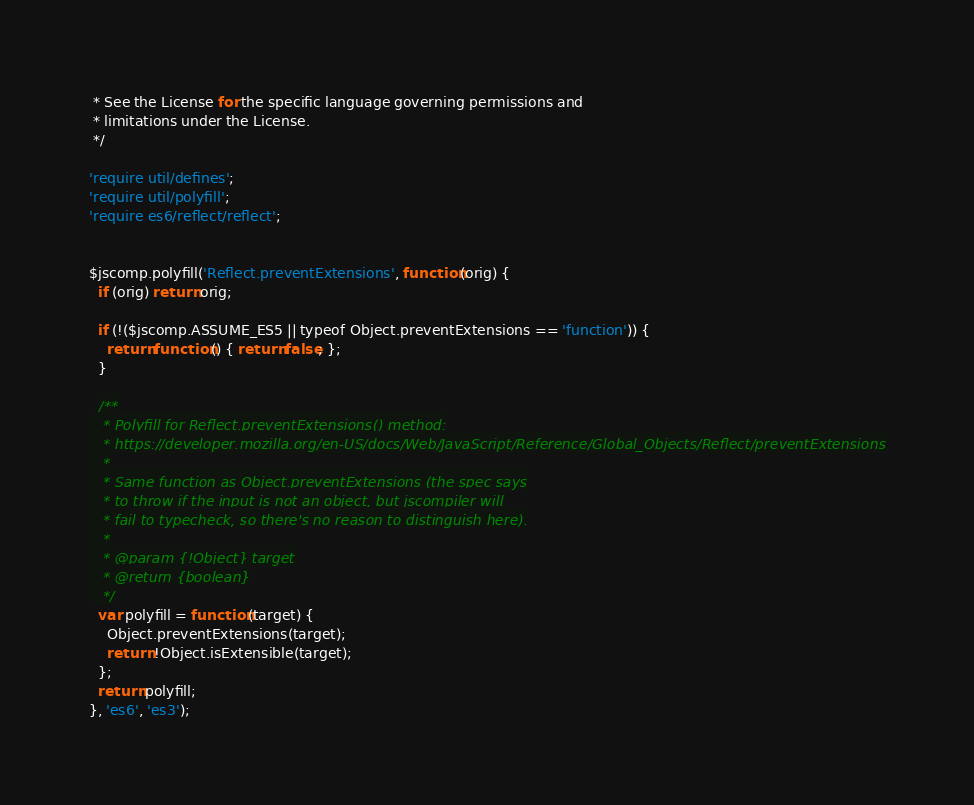<code> <loc_0><loc_0><loc_500><loc_500><_JavaScript_> * See the License for the specific language governing permissions and
 * limitations under the License.
 */

'require util/defines';
'require util/polyfill';
'require es6/reflect/reflect';


$jscomp.polyfill('Reflect.preventExtensions', function(orig) {
  if (orig) return orig;

  if (!($jscomp.ASSUME_ES5 || typeof Object.preventExtensions == 'function')) {
    return function() { return false; };
  }

  /**
   * Polyfill for Reflect.preventExtensions() method:
   * https://developer.mozilla.org/en-US/docs/Web/JavaScript/Reference/Global_Objects/Reflect/preventExtensions
   *
   * Same function as Object.preventExtensions (the spec says
   * to throw if the input is not an object, but jscompiler will
   * fail to typecheck, so there's no reason to distinguish here).
   *
   * @param {!Object} target
   * @return {boolean}
   */
  var polyfill = function(target) {
    Object.preventExtensions(target);
    return !Object.isExtensible(target);
  };
  return polyfill;
}, 'es6', 'es3');
</code> 